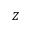<formula> <loc_0><loc_0><loc_500><loc_500>Z</formula> 